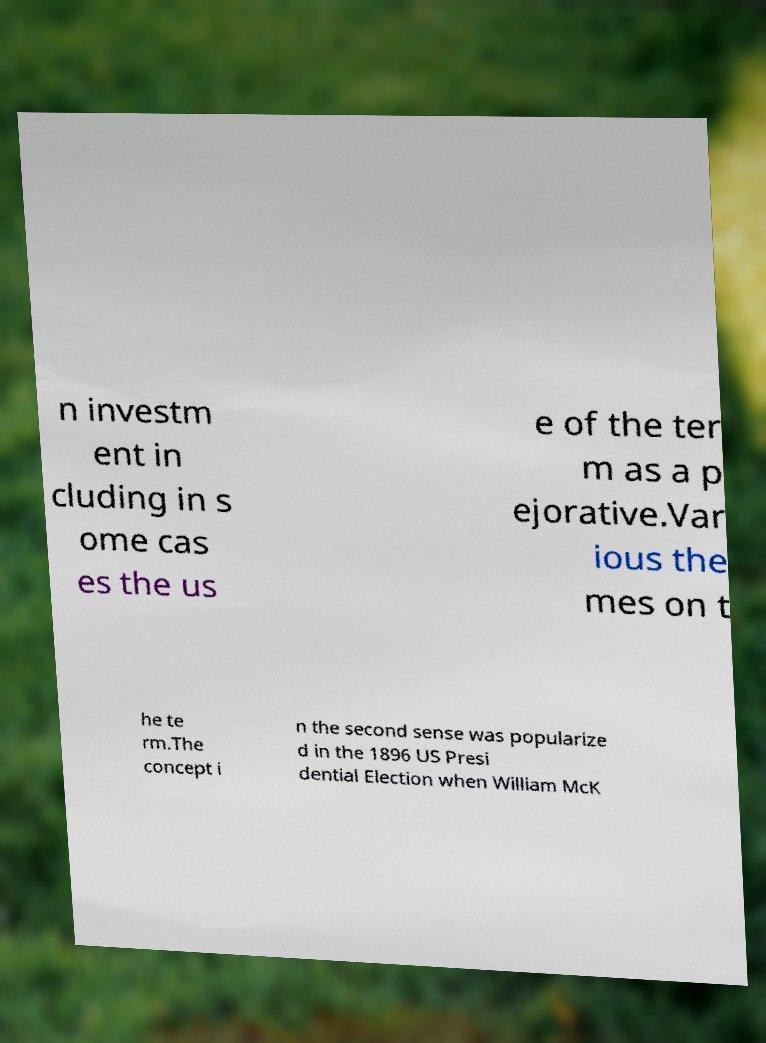There's text embedded in this image that I need extracted. Can you transcribe it verbatim? n investm ent in cluding in s ome cas es the us e of the ter m as a p ejorative.Var ious the mes on t he te rm.The concept i n the second sense was popularize d in the 1896 US Presi dential Election when William McK 